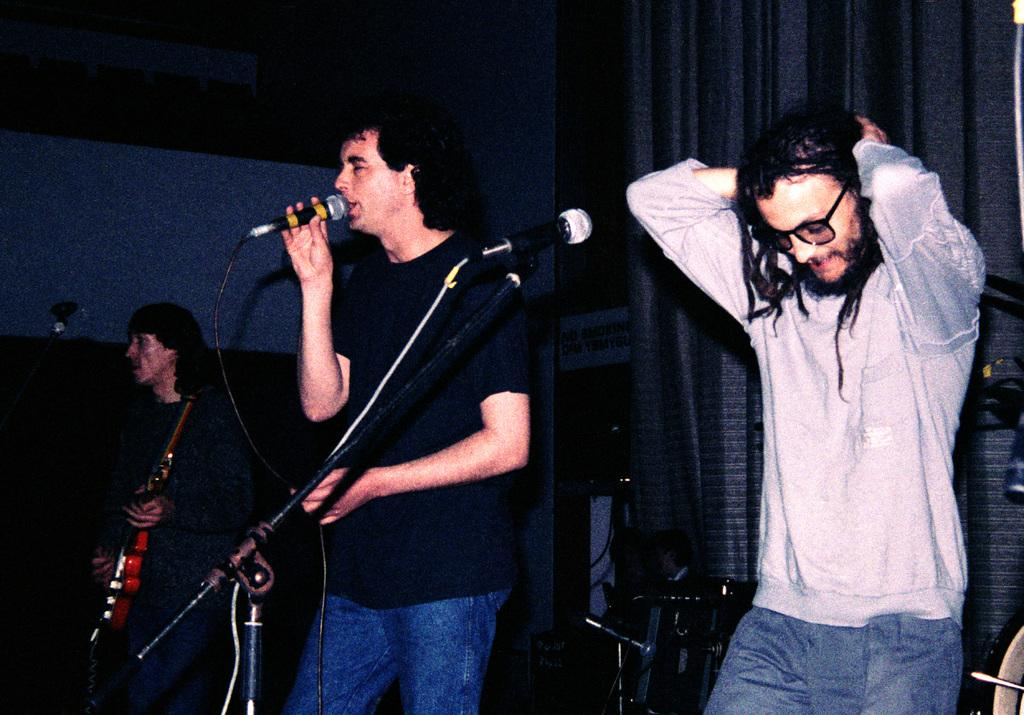How many people are in the image? There are three persons in the image. What are two of the persons doing in the image? Two of the persons are sitting with a microphone. What is the third person doing in the image? One person is playing a guitar. What type of beef is being served on a plate in the image? There is no beef present in the image; it features three persons, two with a microphone and one playing a guitar. 